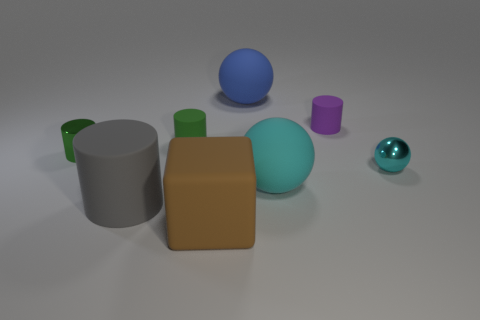Can you describe the position and color of the largest object in the scene? The largest object in the scene is a beige cube. It's positioned in the foreground slightly to the left of the center, dominating the visual field due to its size and central placement. 